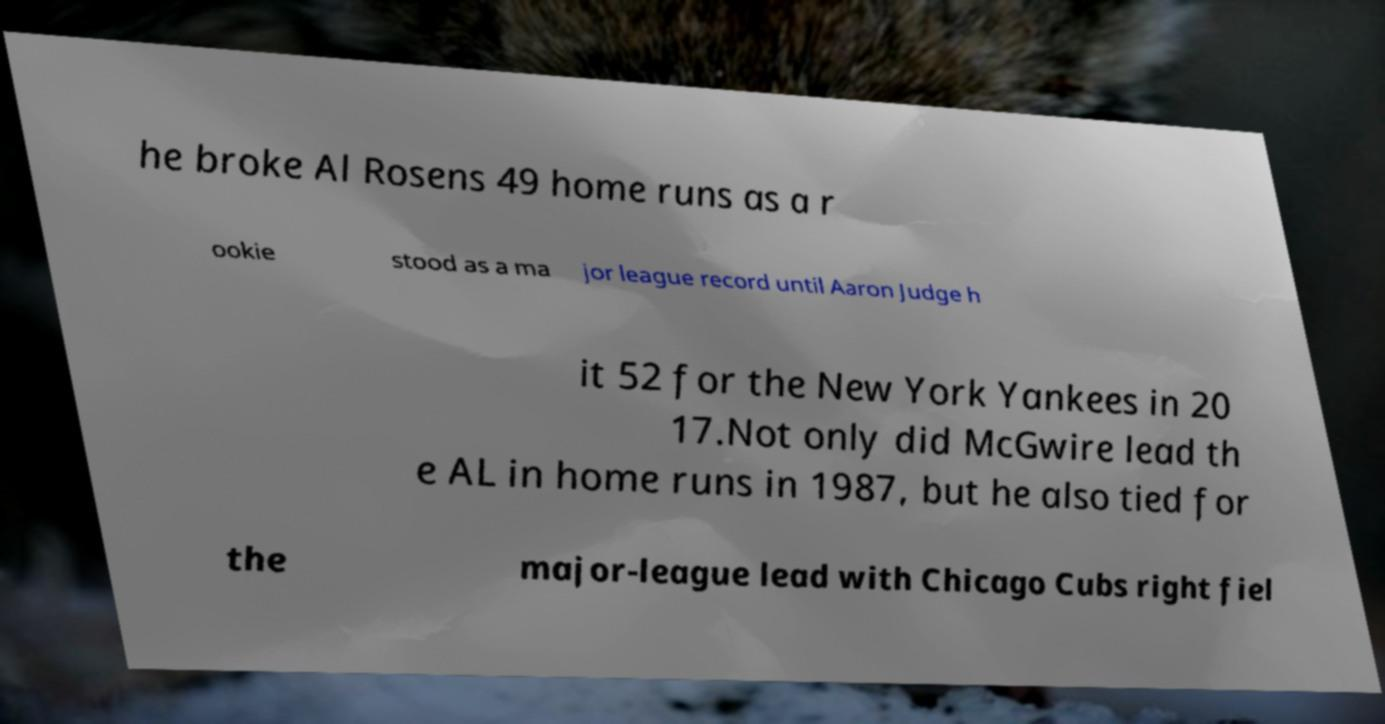Please read and relay the text visible in this image. What does it say? he broke Al Rosens 49 home runs as a r ookie stood as a ma jor league record until Aaron Judge h it 52 for the New York Yankees in 20 17.Not only did McGwire lead th e AL in home runs in 1987, but he also tied for the major-league lead with Chicago Cubs right fiel 